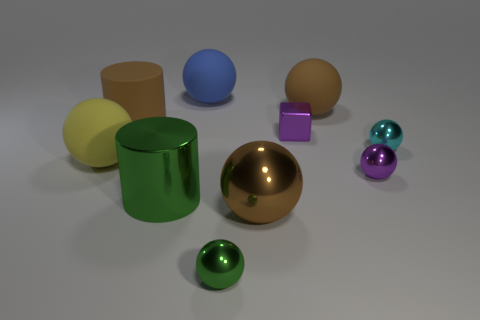Subtract all yellow matte balls. How many balls are left? 6 Subtract all yellow spheres. How many spheres are left? 6 Subtract all blocks. How many objects are left? 9 Subtract 1 balls. How many balls are left? 6 Subtract 1 green spheres. How many objects are left? 9 Subtract all gray spheres. Subtract all purple cylinders. How many spheres are left? 7 Subtract all yellow spheres. How many green cylinders are left? 1 Subtract all tiny gray matte cubes. Subtract all small cyan balls. How many objects are left? 9 Add 8 cylinders. How many cylinders are left? 10 Add 1 brown matte cylinders. How many brown matte cylinders exist? 2 